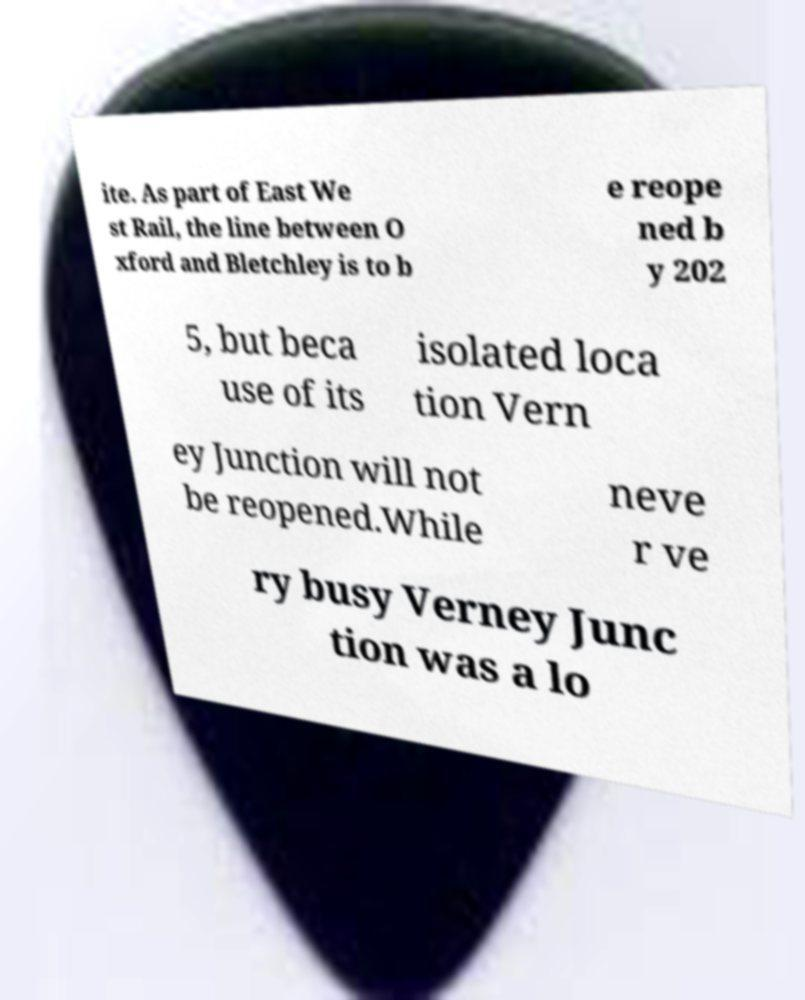Can you read and provide the text displayed in the image?This photo seems to have some interesting text. Can you extract and type it out for me? ite. As part of East We st Rail, the line between O xford and Bletchley is to b e reope ned b y 202 5, but beca use of its isolated loca tion Vern ey Junction will not be reopened.While neve r ve ry busy Verney Junc tion was a lo 